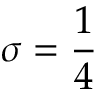Convert formula to latex. <formula><loc_0><loc_0><loc_500><loc_500>\sigma = \frac { 1 } { 4 }</formula> 